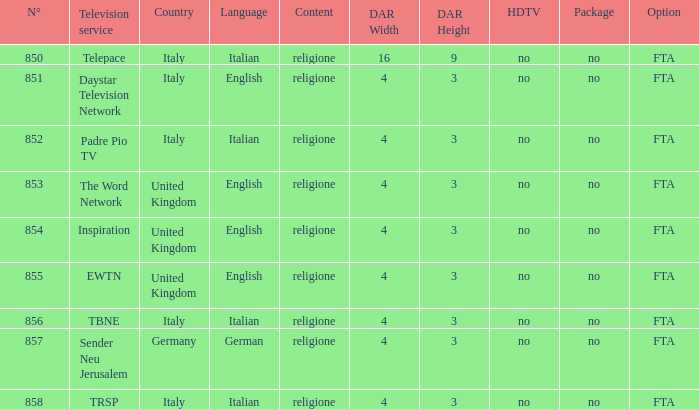How many television service are in italian and n°is greater than 856.0? TRSP. 